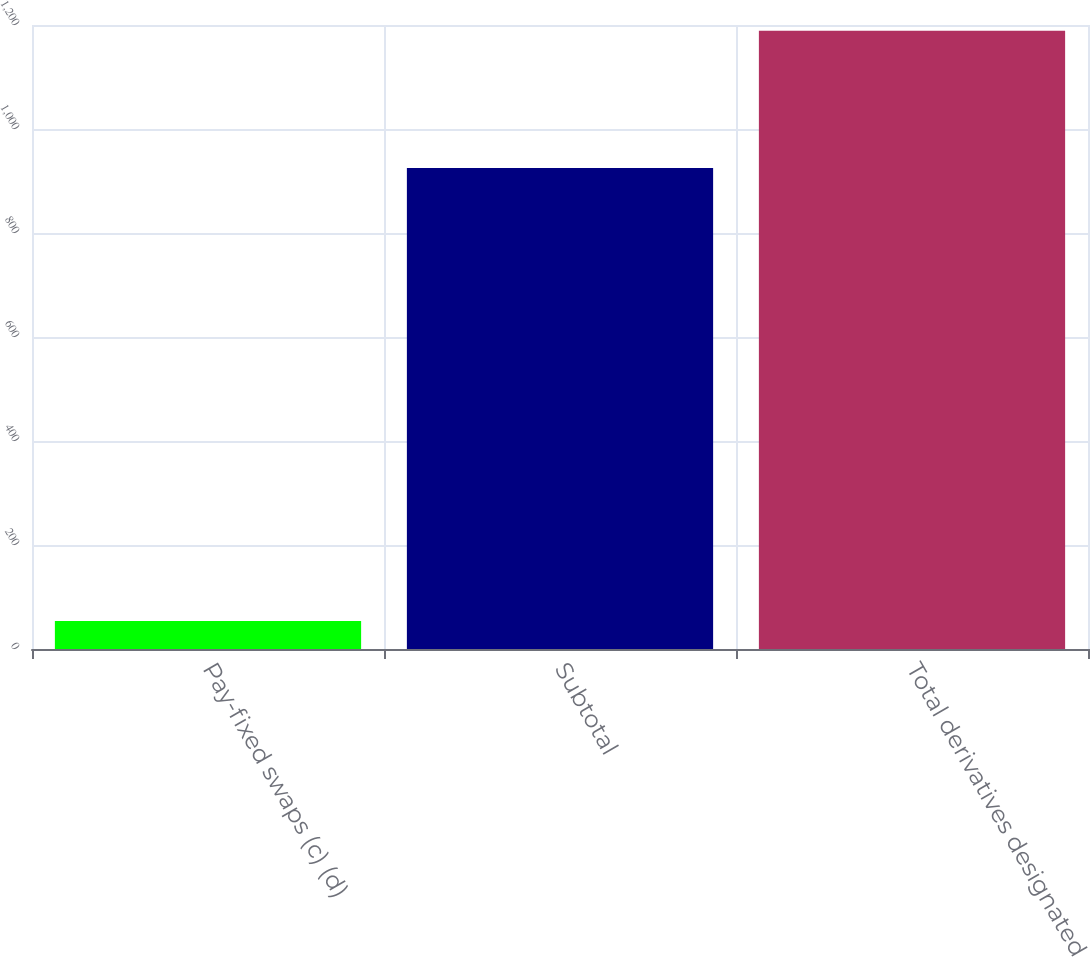<chart> <loc_0><loc_0><loc_500><loc_500><bar_chart><fcel>Pay-fixed swaps (c) (d)<fcel>Subtotal<fcel>Total derivatives designated<nl><fcel>54<fcel>925<fcel>1189<nl></chart> 